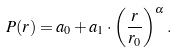<formula> <loc_0><loc_0><loc_500><loc_500>P ( r ) = a _ { 0 } + a _ { 1 } \cdot \left ( \frac { r } { r _ { 0 } } \right ) ^ { \alpha } .</formula> 